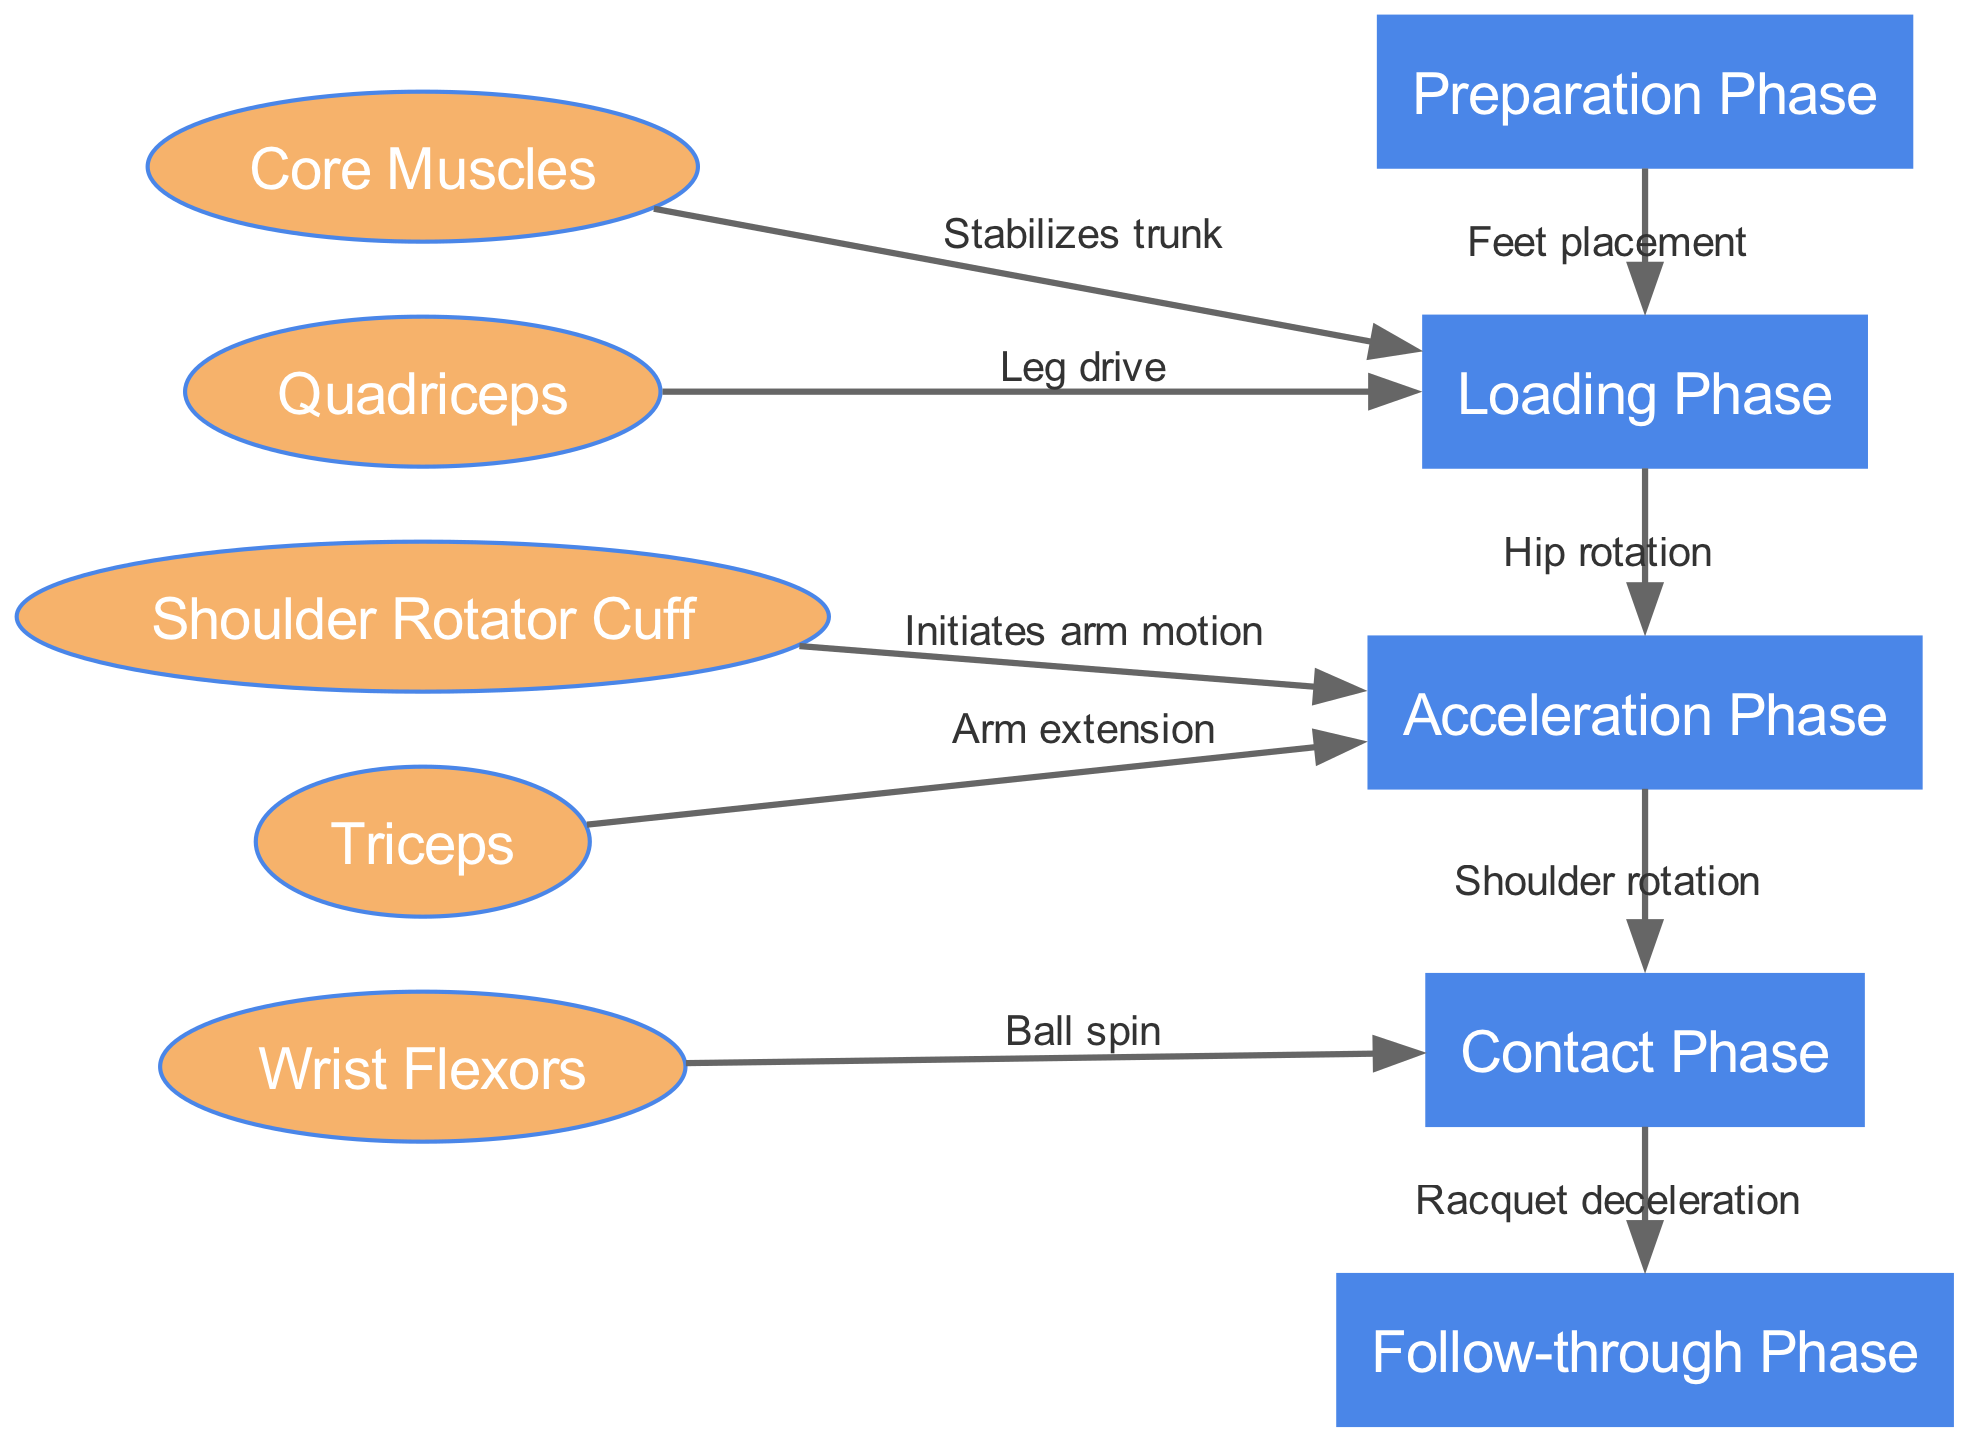What is the first phase of the tennis serve? The diagram clearly labels the first phase as "Preparation Phase." This node is positioned at the start of the flow, leading to subsequent phases.
Answer: Preparation Phase How many muscle groups are illustrated in the diagram? The diagram includes five distinct muscle groups, indicated by the nodes shaped like ellipses. These are "Core Muscles," "Shoulder Rotator Cuff," "Quadriceps," "Triceps," and "Wrist Flexors."
Answer: 5 What action takes place between the Loading Phase and the Acceleration Phase? According to the edges connecting the nodes, the action between the Loading Phase and the Acceleration Phase is defined as "Hip rotation," indicating a transition in movement mechanics from loading to acceleration.
Answer: Hip rotation Which muscle group is responsible for initiating arm motion? The "Shoulder Rotator Cuff" is the muscle group indicated to initiate arm motion, as per the connecting edge that illustrates its influence during the Acceleration Phase.
Answer: Shoulder Rotator Cuff What happens during the Contact Phase? The Contact Phase is described by the node labeled "Contact Phase," with an associated edge leading to the Follow-through Phase that states "Racquet deceleration," showing the action taking place during this phase.
Answer: Racquet deceleration What connects the core muscles to the Loading Phase? The edge labeled "Stabilizes trunk" illustrates the connection between "Core Muscles" and the Loading Phase, indicating the role of core muscles in stabilizing the athlete's trunk during this phase.
Answer: Stabilizes trunk How does the Acceleration Phase relate to the Contact Phase in terms of shoulder motion? The diagram specifies that during the transition from the Acceleration Phase to the Contact Phase, "Shoulder rotation" occurs, indicating a critical movement involving the shoulder as the serve progresses to contact.
Answer: Shoulder rotation What is the purpose of Wrist Flexors during the serve? The "Wrist Flexors" are linked to the Contact Phase, highlighting their function in influencing "Ball spin," which is essential for the effectiveness of the serve.
Answer: Ball spin 